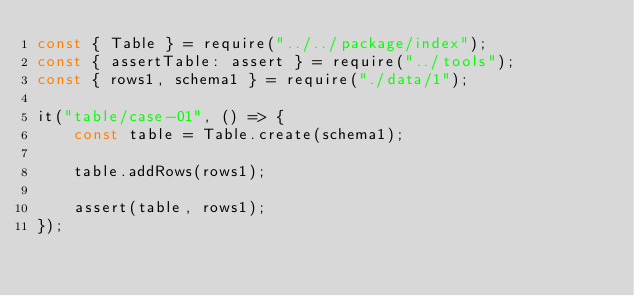<code> <loc_0><loc_0><loc_500><loc_500><_JavaScript_>const { Table } = require("../../package/index");
const { assertTable: assert } = require("../tools");
const { rows1, schema1 } = require("./data/1");

it("table/case-01", () => {
    const table = Table.create(schema1);

    table.addRows(rows1);

    assert(table, rows1);
});
</code> 